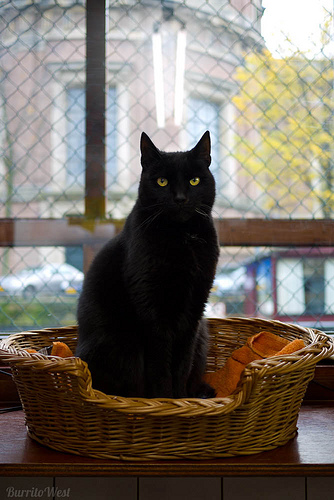<image>
Is the cat on the basket? Yes. Looking at the image, I can see the cat is positioned on top of the basket, with the basket providing support. Is the cat above the basket? No. The cat is not positioned above the basket. The vertical arrangement shows a different relationship. 